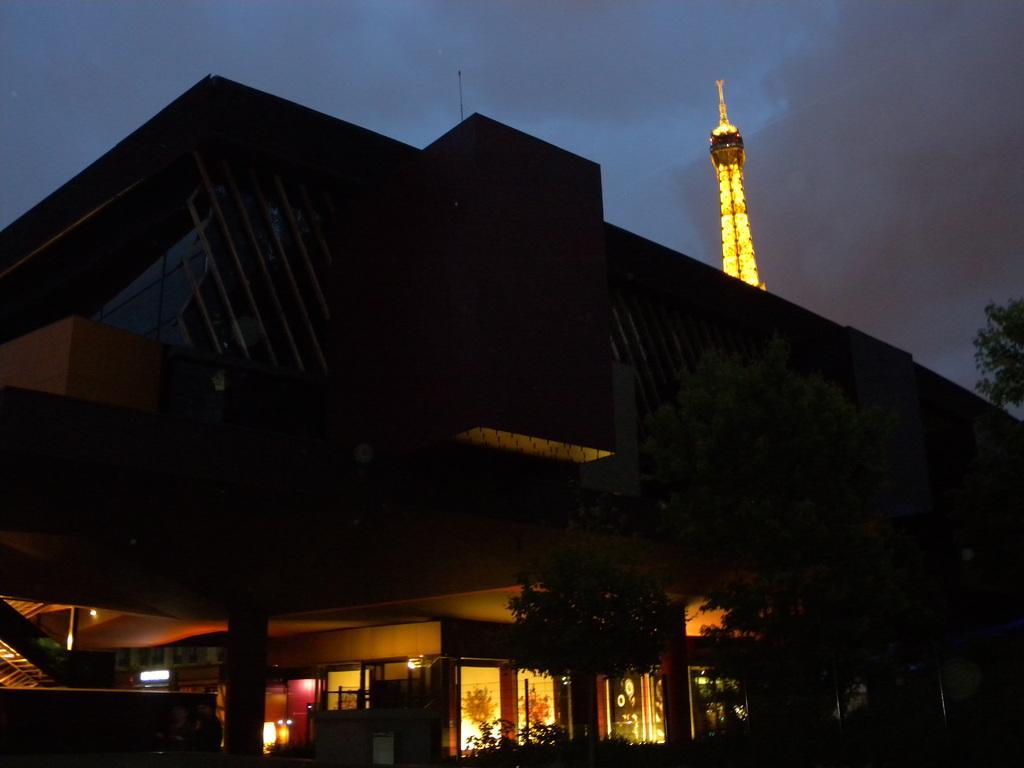Can you describe this image briefly? In this image we can see tower, buildings, trees, electric lights, staircases and sky with clouds. 